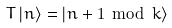Convert formula to latex. <formula><loc_0><loc_0><loc_500><loc_500>T \left | n \right \rangle = \left | n + 1 \, \bmod \, k \right \rangle</formula> 